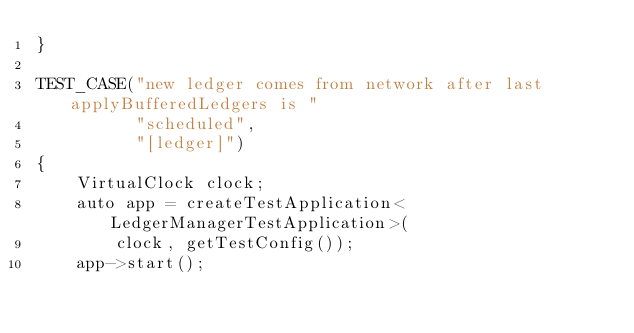Convert code to text. <code><loc_0><loc_0><loc_500><loc_500><_C++_>}

TEST_CASE("new ledger comes from network after last applyBufferedLedgers is "
          "scheduled",
          "[ledger]")
{
    VirtualClock clock;
    auto app = createTestApplication<LedgerManagerTestApplication>(
        clock, getTestConfig());
    app->start();
</code> 